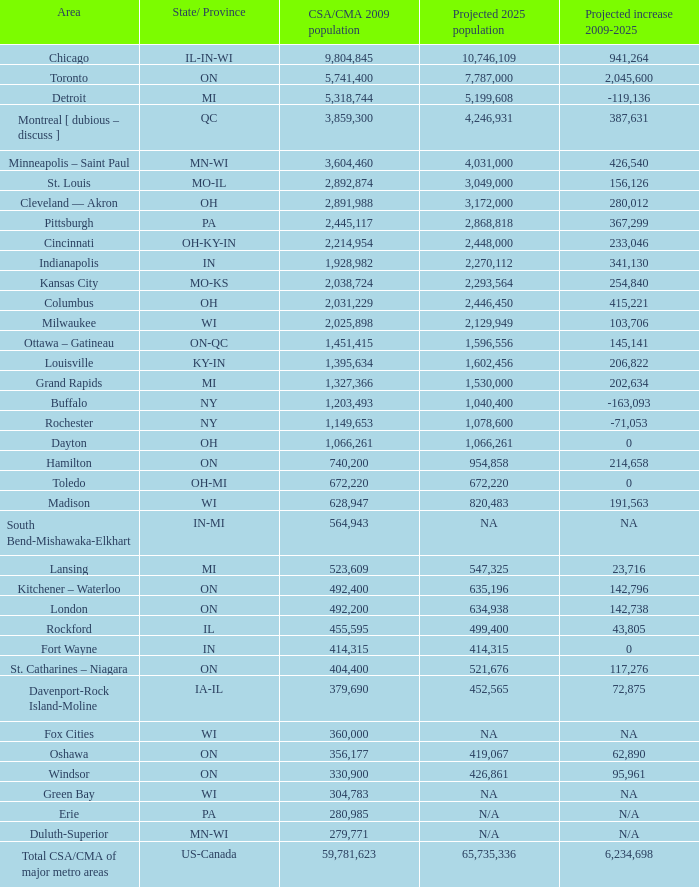What's the CSA/CMA Population in IA-IL? 379690.0. 